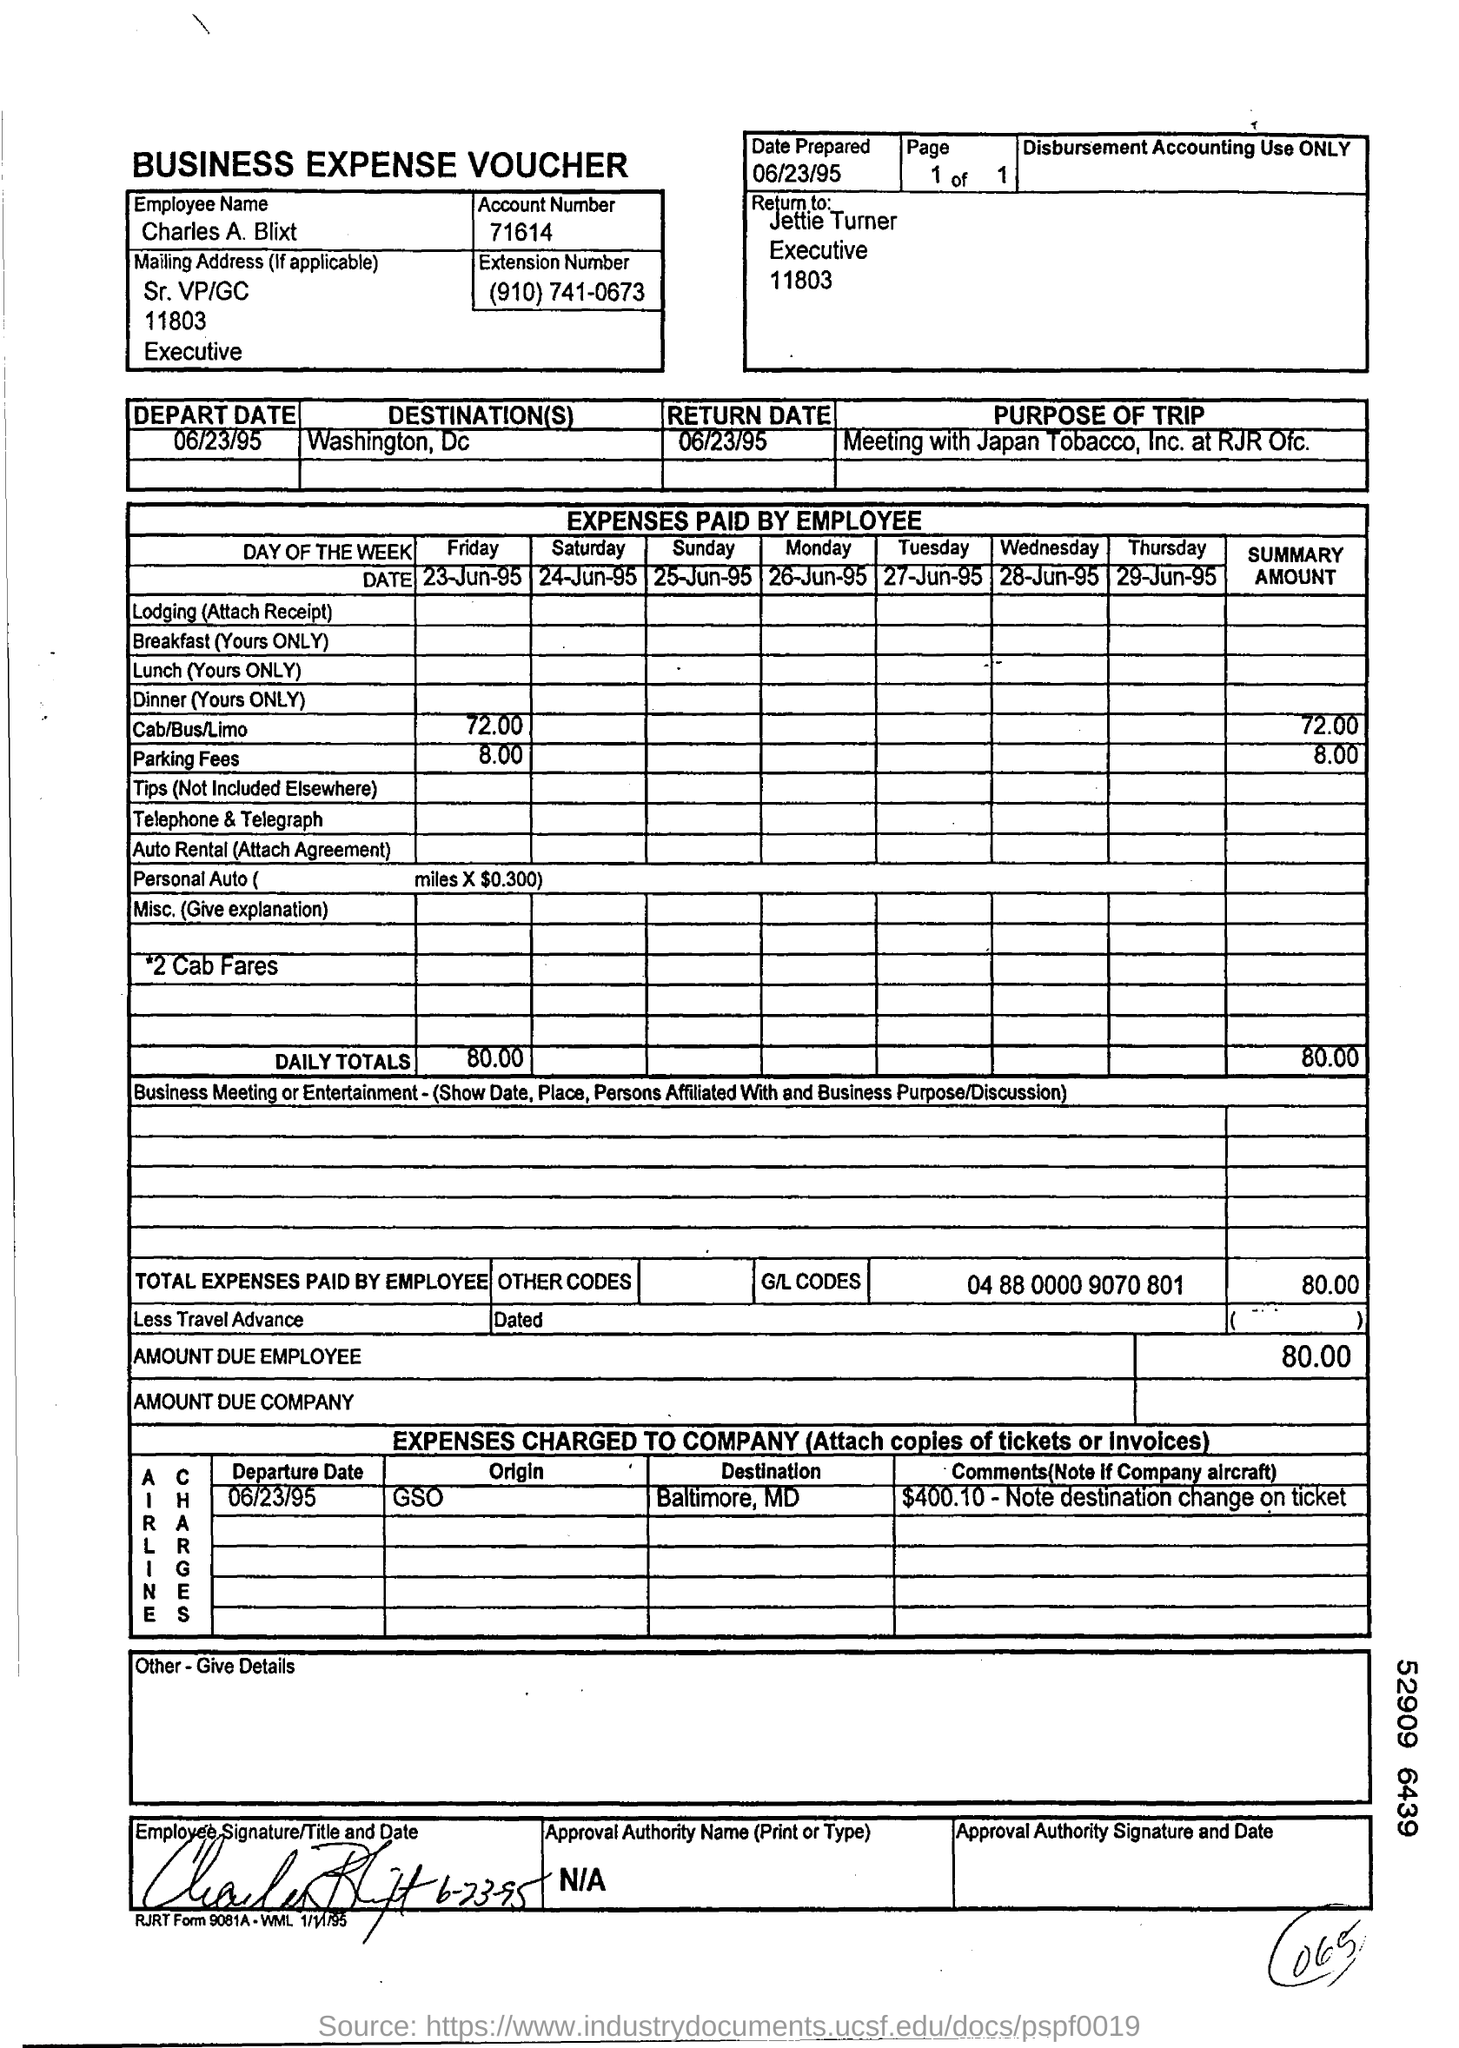Who should it be returned to?
Provide a short and direct response. Jettie Turner. When is the date prepared?
Your answer should be very brief. 06/23/95. What is the employee name?
Give a very brief answer. Charles A. Blixt. Wat is the Account Number?
Provide a succinct answer. 71614. What is the Extension Number?
Offer a terse response. (910) 741-0673. When is the depart date?
Offer a very short reply. 06/23/95. What is the Destination?
Your answer should be compact. Washington, Dc. When is the Return date?
Offer a terse response. 06/23/95. What is the Summary Amount for Cab/Bus/Limo?
Give a very brief answer. 72.00. What is the summary amount for parking fees?
Offer a terse response. 8.00. 